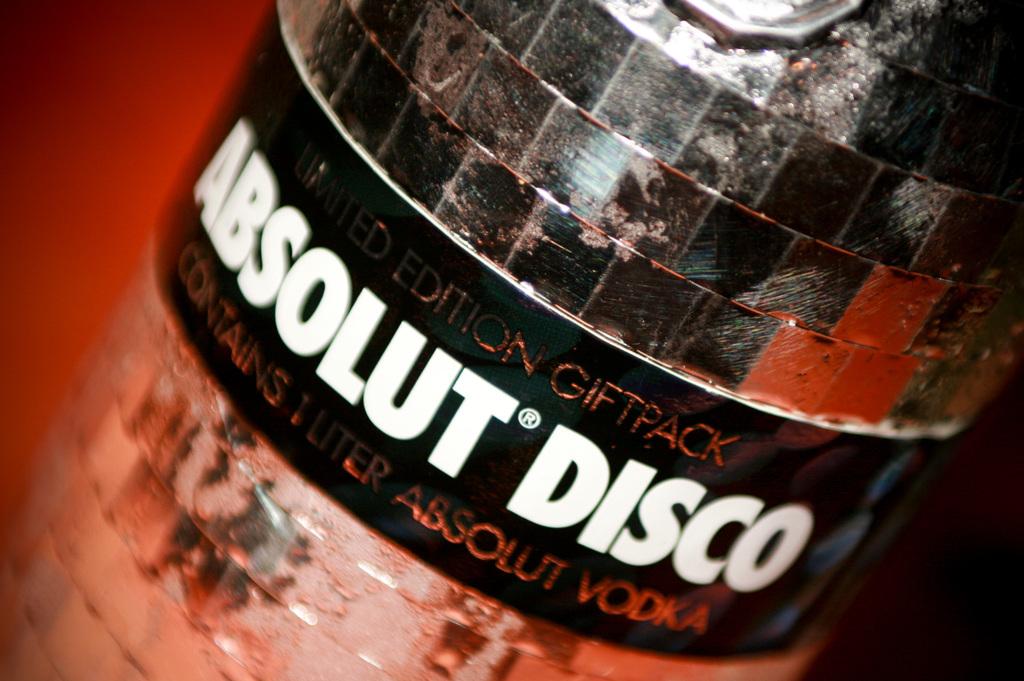What is the name on the label?
Offer a very short reply. Absolut disco. Is this a giftpack?
Make the answer very short. Yes. 